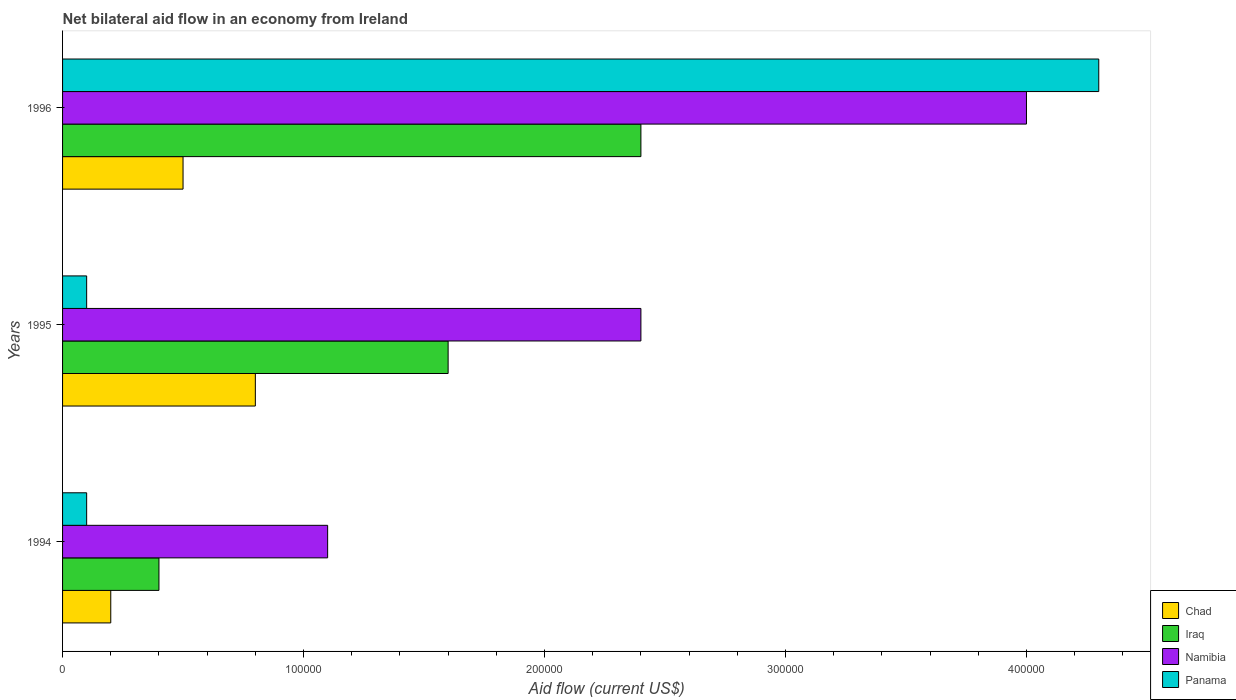How many different coloured bars are there?
Give a very brief answer. 4. Are the number of bars per tick equal to the number of legend labels?
Provide a succinct answer. Yes. Are the number of bars on each tick of the Y-axis equal?
Keep it short and to the point. Yes. What is the net bilateral aid flow in Chad in 1996?
Make the answer very short. 5.00e+04. Across all years, what is the maximum net bilateral aid flow in Panama?
Make the answer very short. 4.30e+05. Across all years, what is the minimum net bilateral aid flow in Panama?
Give a very brief answer. 10000. What is the average net bilateral aid flow in Namibia per year?
Your response must be concise. 2.50e+05. In the year 1994, what is the difference between the net bilateral aid flow in Panama and net bilateral aid flow in Chad?
Offer a terse response. -10000. In how many years, is the net bilateral aid flow in Namibia greater than 300000 US$?
Give a very brief answer. 1. What is the difference between the highest and the lowest net bilateral aid flow in Chad?
Give a very brief answer. 6.00e+04. Is it the case that in every year, the sum of the net bilateral aid flow in Iraq and net bilateral aid flow in Panama is greater than the sum of net bilateral aid flow in Chad and net bilateral aid flow in Namibia?
Provide a succinct answer. No. What does the 1st bar from the top in 1995 represents?
Provide a short and direct response. Panama. What does the 2nd bar from the bottom in 1996 represents?
Keep it short and to the point. Iraq. Is it the case that in every year, the sum of the net bilateral aid flow in Chad and net bilateral aid flow in Namibia is greater than the net bilateral aid flow in Iraq?
Offer a terse response. Yes. How many bars are there?
Keep it short and to the point. 12. Are all the bars in the graph horizontal?
Provide a short and direct response. Yes. Does the graph contain any zero values?
Keep it short and to the point. No. What is the title of the graph?
Provide a short and direct response. Net bilateral aid flow in an economy from Ireland. What is the label or title of the Y-axis?
Offer a terse response. Years. What is the Aid flow (current US$) in Namibia in 1994?
Offer a very short reply. 1.10e+05. What is the Aid flow (current US$) in Panama in 1994?
Provide a succinct answer. 10000. What is the Aid flow (current US$) of Iraq in 1995?
Your response must be concise. 1.60e+05. What is the Aid flow (current US$) in Namibia in 1995?
Your answer should be compact. 2.40e+05. What is the Aid flow (current US$) in Chad in 1996?
Keep it short and to the point. 5.00e+04. What is the Aid flow (current US$) of Iraq in 1996?
Your response must be concise. 2.40e+05. Across all years, what is the maximum Aid flow (current US$) of Iraq?
Provide a succinct answer. 2.40e+05. Across all years, what is the minimum Aid flow (current US$) in Iraq?
Your response must be concise. 4.00e+04. What is the total Aid flow (current US$) in Chad in the graph?
Offer a terse response. 1.50e+05. What is the total Aid flow (current US$) in Namibia in the graph?
Your answer should be compact. 7.50e+05. What is the difference between the Aid flow (current US$) in Namibia in 1994 and that in 1995?
Provide a short and direct response. -1.30e+05. What is the difference between the Aid flow (current US$) of Iraq in 1994 and that in 1996?
Your answer should be very brief. -2.00e+05. What is the difference between the Aid flow (current US$) of Namibia in 1994 and that in 1996?
Ensure brevity in your answer.  -2.90e+05. What is the difference between the Aid flow (current US$) of Panama in 1994 and that in 1996?
Your answer should be very brief. -4.20e+05. What is the difference between the Aid flow (current US$) of Panama in 1995 and that in 1996?
Your answer should be very brief. -4.20e+05. What is the difference between the Aid flow (current US$) in Chad in 1994 and the Aid flow (current US$) in Iraq in 1995?
Offer a very short reply. -1.40e+05. What is the difference between the Aid flow (current US$) of Chad in 1994 and the Aid flow (current US$) of Namibia in 1995?
Offer a very short reply. -2.20e+05. What is the difference between the Aid flow (current US$) of Iraq in 1994 and the Aid flow (current US$) of Panama in 1995?
Your answer should be compact. 3.00e+04. What is the difference between the Aid flow (current US$) in Namibia in 1994 and the Aid flow (current US$) in Panama in 1995?
Your response must be concise. 1.00e+05. What is the difference between the Aid flow (current US$) in Chad in 1994 and the Aid flow (current US$) in Iraq in 1996?
Your answer should be very brief. -2.20e+05. What is the difference between the Aid flow (current US$) of Chad in 1994 and the Aid flow (current US$) of Namibia in 1996?
Make the answer very short. -3.80e+05. What is the difference between the Aid flow (current US$) in Chad in 1994 and the Aid flow (current US$) in Panama in 1996?
Your response must be concise. -4.10e+05. What is the difference between the Aid flow (current US$) in Iraq in 1994 and the Aid flow (current US$) in Namibia in 1996?
Your answer should be compact. -3.60e+05. What is the difference between the Aid flow (current US$) in Iraq in 1994 and the Aid flow (current US$) in Panama in 1996?
Give a very brief answer. -3.90e+05. What is the difference between the Aid flow (current US$) of Namibia in 1994 and the Aid flow (current US$) of Panama in 1996?
Offer a very short reply. -3.20e+05. What is the difference between the Aid flow (current US$) of Chad in 1995 and the Aid flow (current US$) of Iraq in 1996?
Give a very brief answer. -1.60e+05. What is the difference between the Aid flow (current US$) of Chad in 1995 and the Aid flow (current US$) of Namibia in 1996?
Make the answer very short. -3.20e+05. What is the difference between the Aid flow (current US$) of Chad in 1995 and the Aid flow (current US$) of Panama in 1996?
Offer a very short reply. -3.50e+05. What is the difference between the Aid flow (current US$) of Iraq in 1995 and the Aid flow (current US$) of Namibia in 1996?
Offer a terse response. -2.40e+05. What is the difference between the Aid flow (current US$) of Namibia in 1995 and the Aid flow (current US$) of Panama in 1996?
Provide a succinct answer. -1.90e+05. What is the average Aid flow (current US$) in Chad per year?
Offer a very short reply. 5.00e+04. What is the average Aid flow (current US$) of Iraq per year?
Ensure brevity in your answer.  1.47e+05. What is the average Aid flow (current US$) of Panama per year?
Ensure brevity in your answer.  1.50e+05. In the year 1994, what is the difference between the Aid flow (current US$) in Chad and Aid flow (current US$) in Iraq?
Provide a short and direct response. -2.00e+04. In the year 1994, what is the difference between the Aid flow (current US$) of Chad and Aid flow (current US$) of Namibia?
Offer a terse response. -9.00e+04. In the year 1994, what is the difference between the Aid flow (current US$) of Namibia and Aid flow (current US$) of Panama?
Ensure brevity in your answer.  1.00e+05. In the year 1995, what is the difference between the Aid flow (current US$) in Iraq and Aid flow (current US$) in Namibia?
Your answer should be very brief. -8.00e+04. In the year 1995, what is the difference between the Aid flow (current US$) in Iraq and Aid flow (current US$) in Panama?
Offer a terse response. 1.50e+05. In the year 1996, what is the difference between the Aid flow (current US$) of Chad and Aid flow (current US$) of Namibia?
Offer a terse response. -3.50e+05. In the year 1996, what is the difference between the Aid flow (current US$) of Chad and Aid flow (current US$) of Panama?
Offer a terse response. -3.80e+05. In the year 1996, what is the difference between the Aid flow (current US$) in Iraq and Aid flow (current US$) in Namibia?
Give a very brief answer. -1.60e+05. In the year 1996, what is the difference between the Aid flow (current US$) in Iraq and Aid flow (current US$) in Panama?
Your answer should be very brief. -1.90e+05. What is the ratio of the Aid flow (current US$) in Iraq in 1994 to that in 1995?
Provide a succinct answer. 0.25. What is the ratio of the Aid flow (current US$) of Namibia in 1994 to that in 1995?
Provide a succinct answer. 0.46. What is the ratio of the Aid flow (current US$) in Panama in 1994 to that in 1995?
Keep it short and to the point. 1. What is the ratio of the Aid flow (current US$) of Namibia in 1994 to that in 1996?
Offer a terse response. 0.28. What is the ratio of the Aid flow (current US$) of Panama in 1994 to that in 1996?
Your answer should be very brief. 0.02. What is the ratio of the Aid flow (current US$) of Iraq in 1995 to that in 1996?
Make the answer very short. 0.67. What is the ratio of the Aid flow (current US$) of Namibia in 1995 to that in 1996?
Keep it short and to the point. 0.6. What is the ratio of the Aid flow (current US$) of Panama in 1995 to that in 1996?
Give a very brief answer. 0.02. What is the difference between the highest and the second highest Aid flow (current US$) of Chad?
Your answer should be very brief. 3.00e+04. What is the difference between the highest and the second highest Aid flow (current US$) of Iraq?
Offer a very short reply. 8.00e+04. What is the difference between the highest and the lowest Aid flow (current US$) of Chad?
Your answer should be very brief. 6.00e+04. What is the difference between the highest and the lowest Aid flow (current US$) of Panama?
Offer a very short reply. 4.20e+05. 